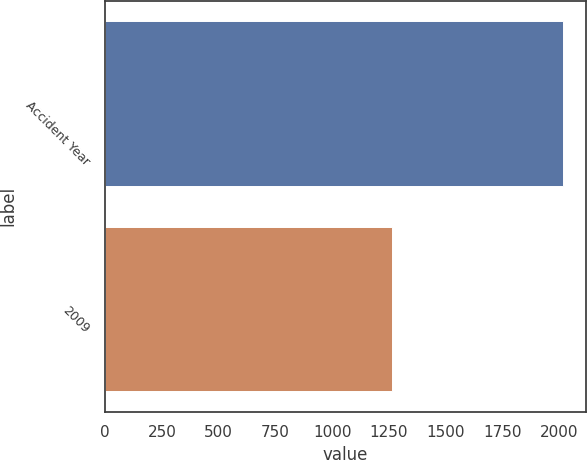<chart> <loc_0><loc_0><loc_500><loc_500><bar_chart><fcel>Accident Year<fcel>2009<nl><fcel>2018<fcel>1263<nl></chart> 